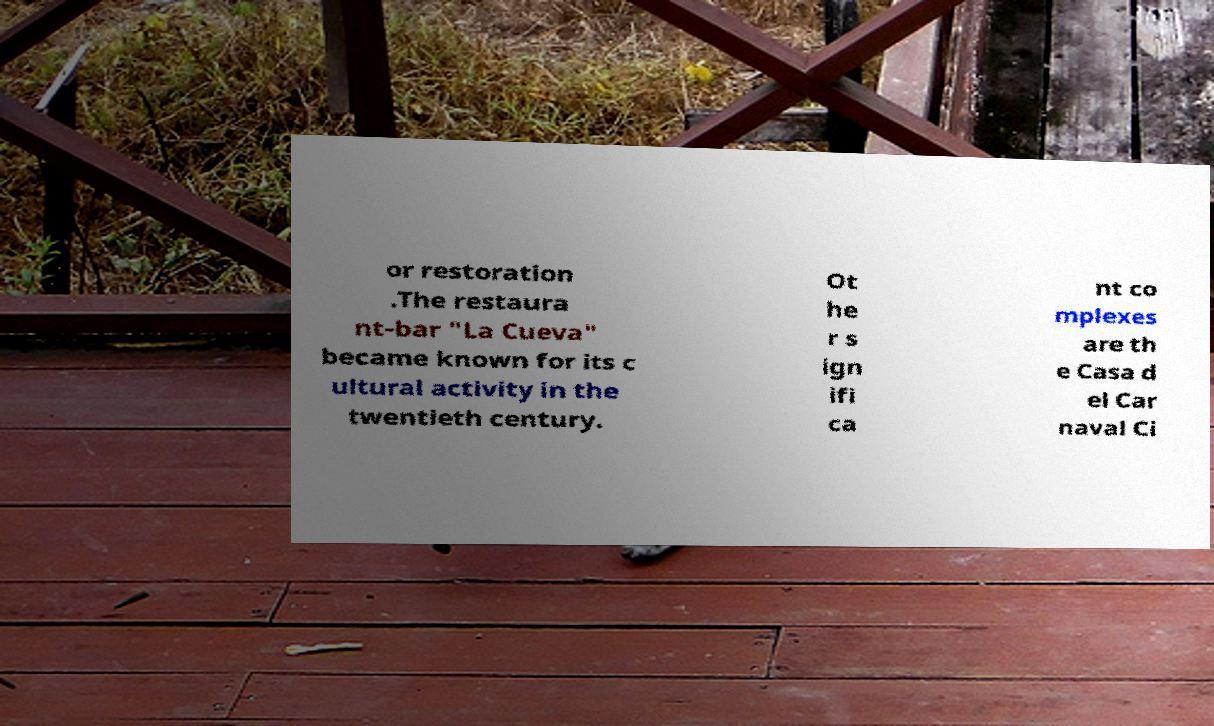I need the written content from this picture converted into text. Can you do that? or restoration .The restaura nt-bar "La Cueva" became known for its c ultural activity in the twentieth century. Ot he r s ign ifi ca nt co mplexes are th e Casa d el Car naval Ci 